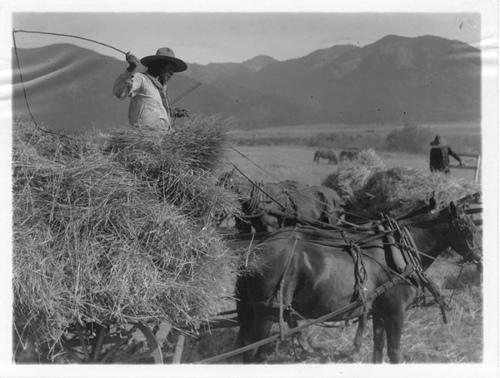What are the horses wearing?
Short answer required. Harness. Is this taken near mountains?
Keep it brief. Yes. What is the man holding in his right hand?
Give a very brief answer. Whip. What is the man hauling in the wagon?
Concise answer only. Hay. 